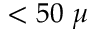<formula> <loc_0><loc_0><loc_500><loc_500>< 5 0 \mu</formula> 